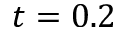Convert formula to latex. <formula><loc_0><loc_0><loc_500><loc_500>t = 0 . 2</formula> 